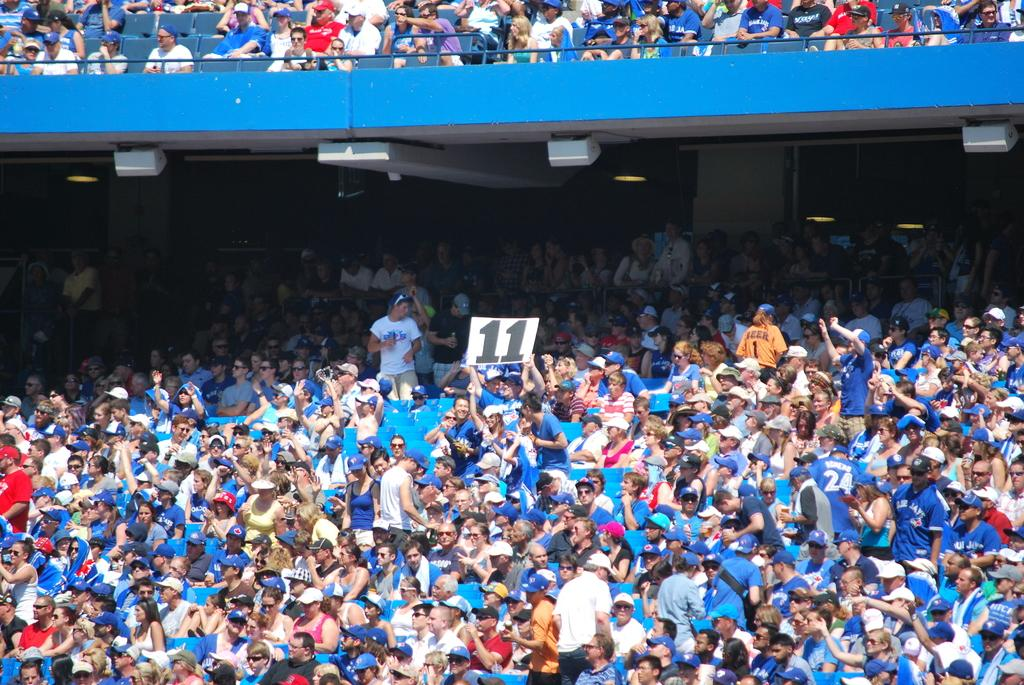What are the people in the image doing? The people in the image are sitting on chairs. Where is the image set? The setting is a stadium. What are some people wearing in the image? Some people in the image are wearing caps. What is the person holding in the image? The person is holding a paper with a number. How many frogs can be seen jumping in the image? There are no frogs present in the image. Is there a reason given for the people sitting in the stadium in the image? The image does not provide a reason for the people sitting in the stadium. 